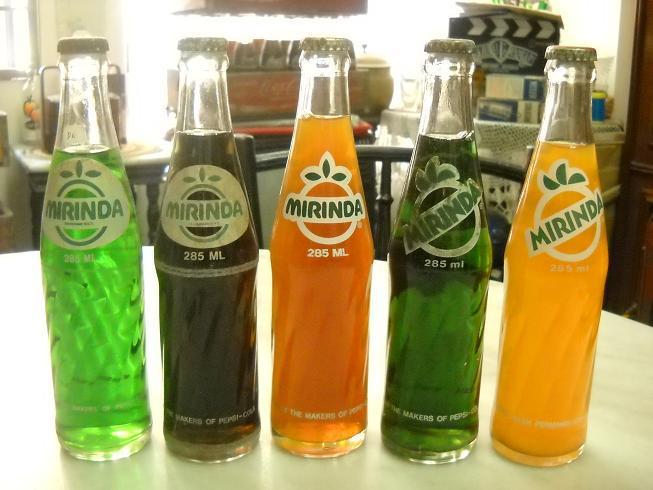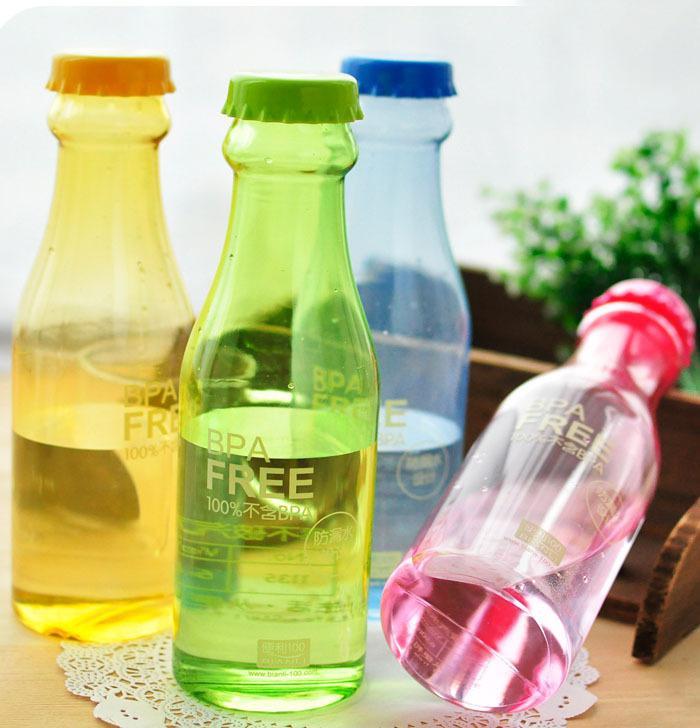The first image is the image on the left, the second image is the image on the right. For the images displayed, is the sentence "There are four uncapped bottles in the left image." factually correct? Answer yes or no. No. The first image is the image on the left, the second image is the image on the right. Analyze the images presented: Is the assertion "There are nine drink bottles in total." valid? Answer yes or no. Yes. 